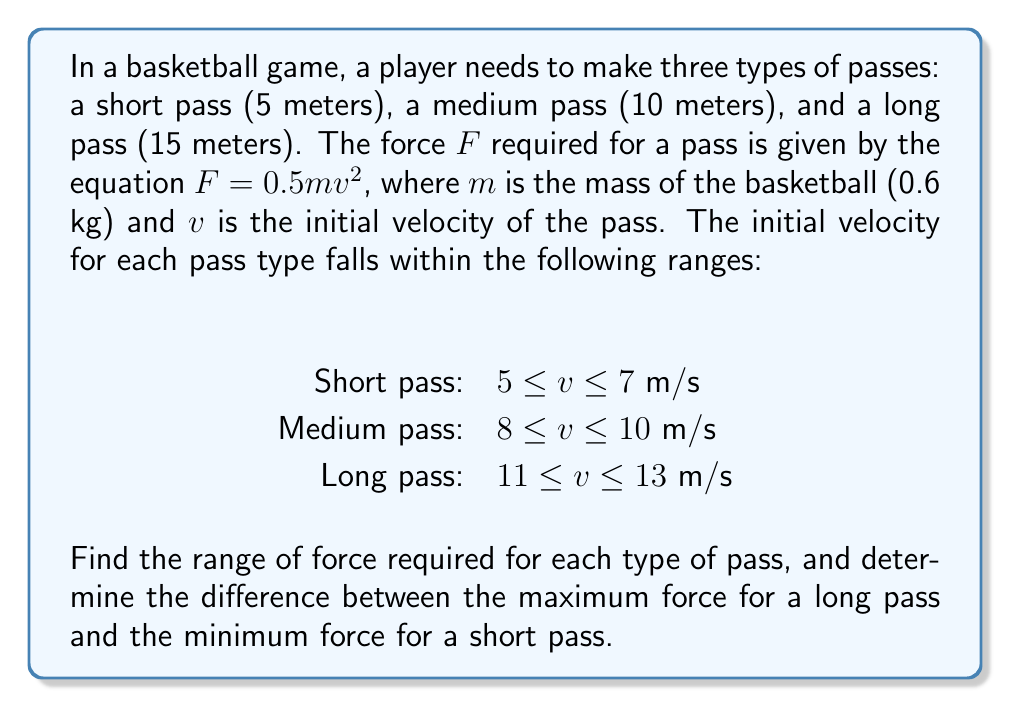Show me your answer to this math problem. Let's solve this step-by-step:

1. We'll use the equation $F = 0.5mv^2$ for each pass type, where $m = 0.6$ kg.

2. Short pass ($5 \leq v \leq 7$ m/s):
   Minimum force: $F_{min} = 0.5 \cdot 0.6 \cdot 5^2 = 7.5$ N
   Maximum force: $F_{max} = 0.5 \cdot 0.6 \cdot 7^2 = 14.7$ N
   Range: $7.5 \leq F \leq 14.7$ N

3. Medium pass ($8 \leq v \leq 10$ m/s):
   Minimum force: $F_{min} = 0.5 \cdot 0.6 \cdot 8^2 = 19.2$ N
   Maximum force: $F_{max} = 0.5 \cdot 0.6 \cdot 10^2 = 30$ N
   Range: $19.2 \leq F \leq 30$ N

4. Long pass ($11 \leq v \leq 13$ m/s):
   Minimum force: $F_{min} = 0.5 \cdot 0.6 \cdot 11^2 = 36.3$ N
   Maximum force: $F_{max} = 0.5 \cdot 0.6 \cdot 13^2 = 50.7$ N
   Range: $36.3 \leq F \leq 50.7$ N

5. Difference between maximum force for long pass and minimum force for short pass:
   $50.7 - 7.5 = 43.2$ N
Answer: Short pass: $7.5 \leq F \leq 14.7$ N
Medium pass: $19.2 \leq F \leq 30$ N
Long pass: $36.3 \leq F \leq 50.7$ N
Difference: 43.2 N 